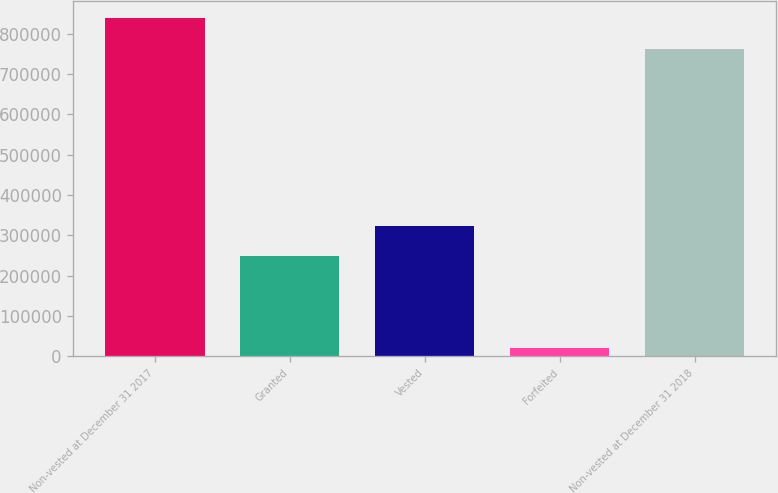Convert chart. <chart><loc_0><loc_0><loc_500><loc_500><bar_chart><fcel>Non-vested at December 31 2017<fcel>Granted<fcel>Vested<fcel>Forfeited<fcel>Non-vested at December 31 2018<nl><fcel>838235<fcel>247532<fcel>323861<fcel>20877<fcel>761906<nl></chart> 